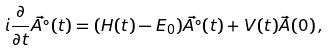Convert formula to latex. <formula><loc_0><loc_0><loc_500><loc_500>i \frac { \partial } { \partial t } \vec { A ^ { \circ } } ( t ) = ( { H } ( t ) - E _ { 0 } ) \vec { A ^ { \circ } } ( t ) + { V } ( t ) \vec { A } ( 0 ) \, ,</formula> 